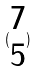<formula> <loc_0><loc_0><loc_500><loc_500>( \begin{matrix} 7 \\ 5 \end{matrix} )</formula> 